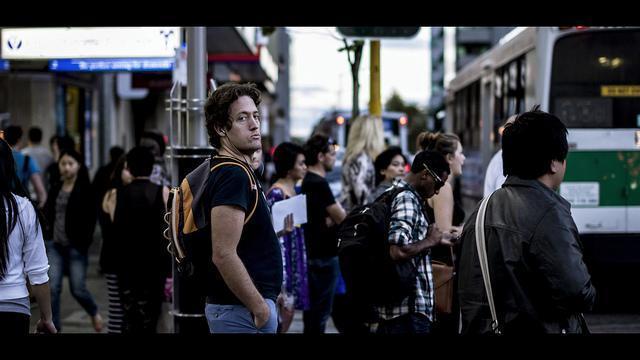How many bald men in this picture?
Give a very brief answer. 0. How many people are there?
Give a very brief answer. 11. How many backpacks are there?
Give a very brief answer. 3. How many animals that are zebras are there? there are animals that aren't zebras too?
Give a very brief answer. 0. 